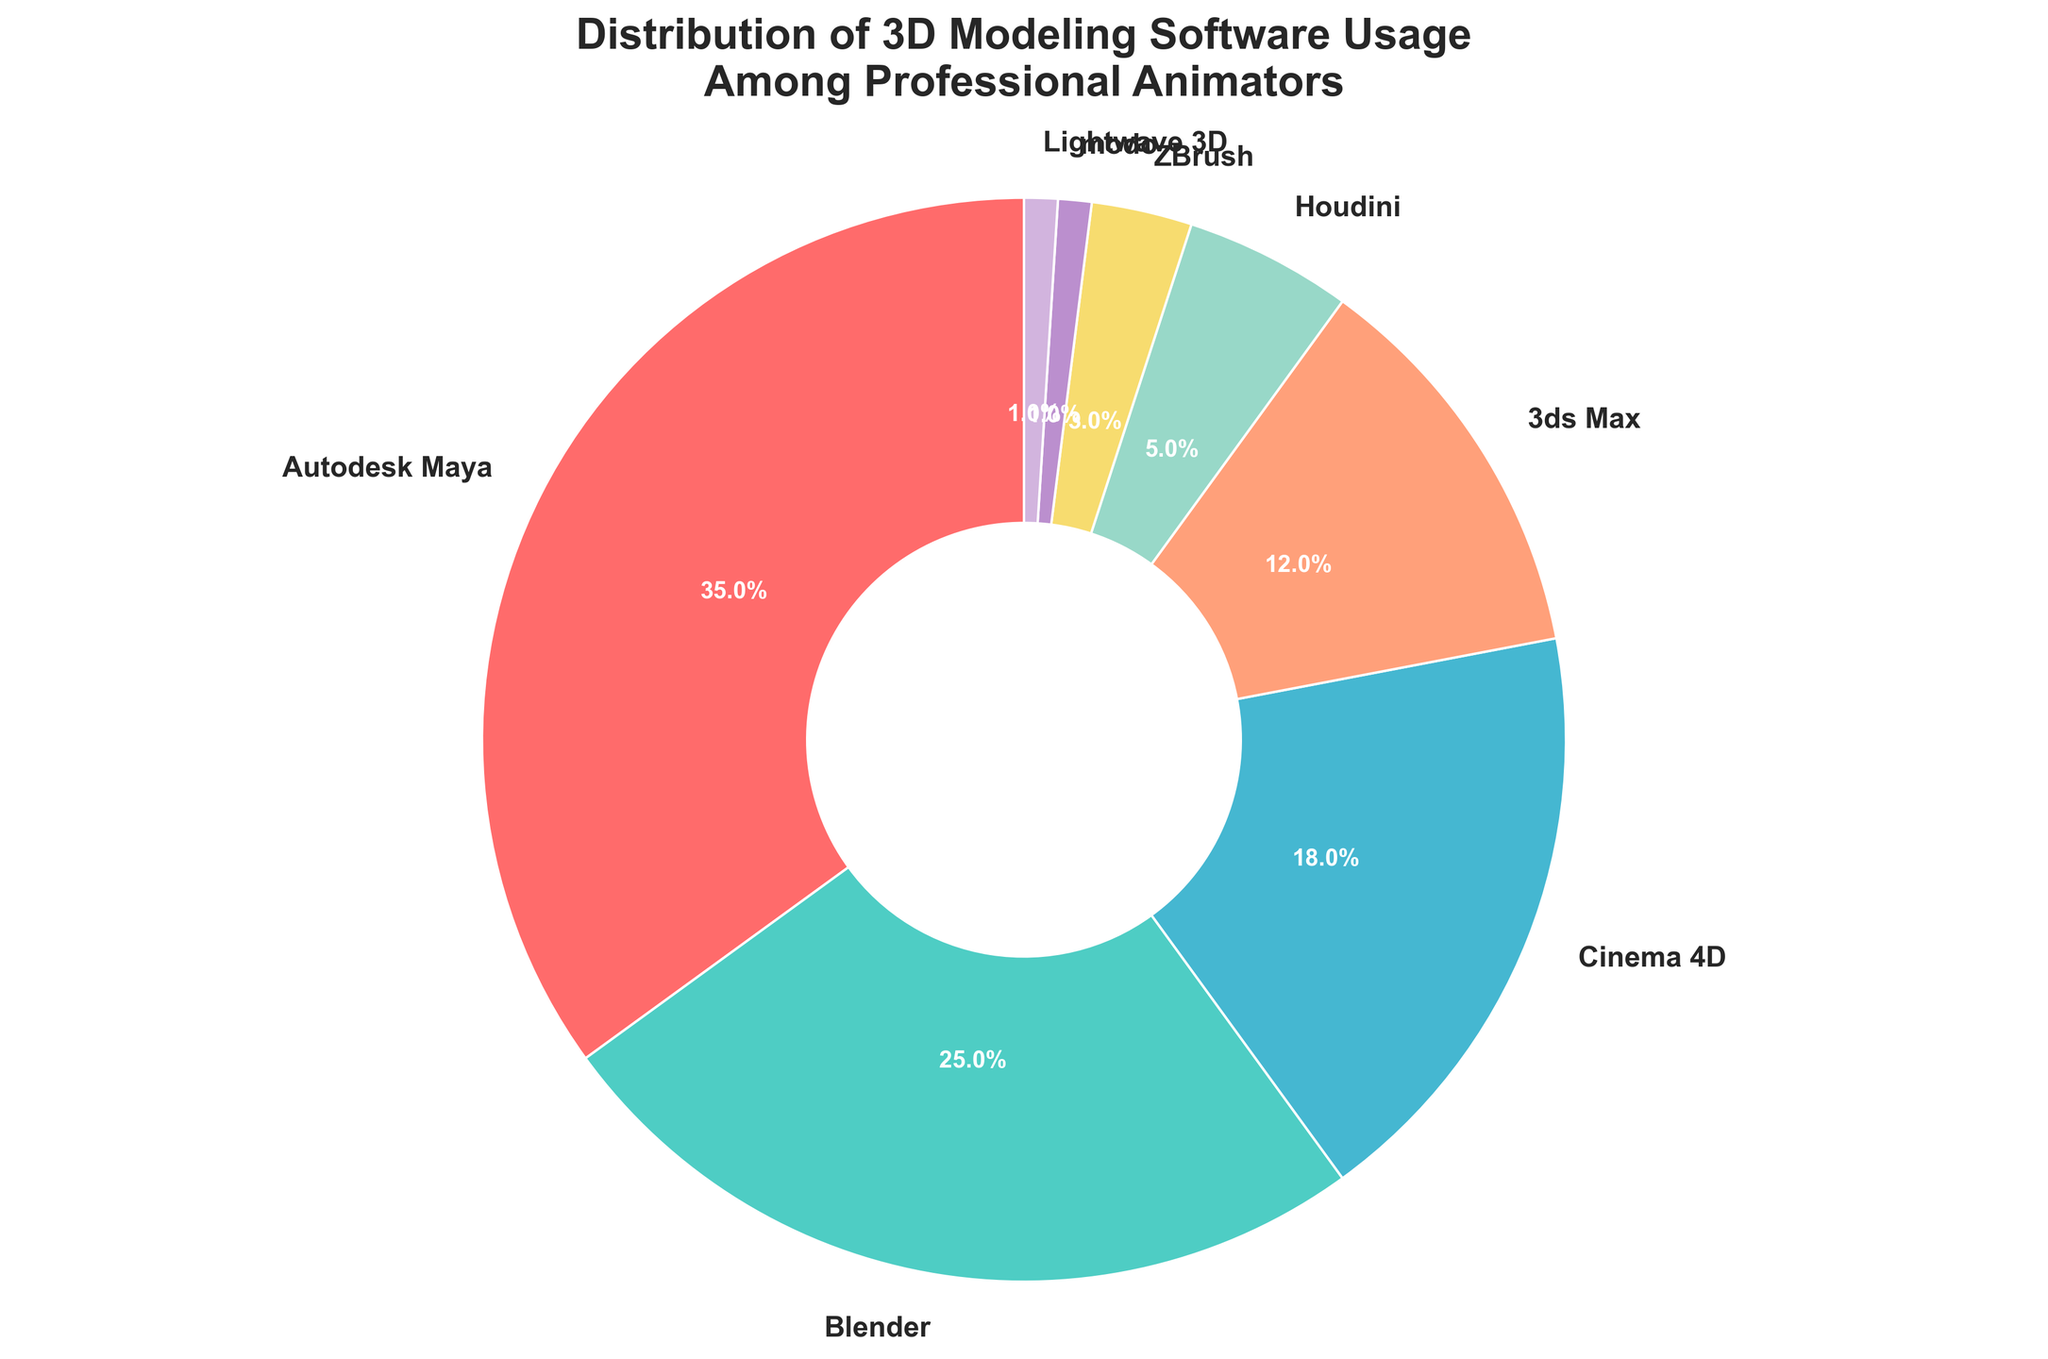What percentage of professional animators use Blender? By looking at the pie chart, find the section labeled "Blender" and read its percentage.
Answer: 25% Which software has the smallest usage percentage among professional animators? By examining the pie chart, identify the segment with the smallest slice, look for the label, which is "Lightwave 3D" or "modo".
Answer: Lightwave 3D or modo How much more popular is Autodesk Maya than 3ds Max? Note the percentages for both Autodesk Maya (35%) and 3ds Max (12%). Subtract the smaller percentage from the bigger one. 35 - 12 = 23
Answer: 23% What is the sum of the percentages for Cinema 4D and Houdini? Identify the percentages for Cinema 4D (18%) and Houdini (5%). Add them together: 18 + 5 = 23
Answer: 23% Which software has a larger share, Blender or Cinema 4D, and by how much? Note the percentages for Blender (25%) and Cinema 4D (18%). Subtract the smaller percentage from the bigger one. 25 - 18 = 7
Answer: Blender by 7% If you combine the usage of ZBrush, modo, and Lightwave 3D, what percentage do you get? Identify the percentages for ZBrush (3%), modo (1%), and Lightwave 3D (1%). Sum them up: 3 + 1 + 1 = 5
Answer: 5% What color represents 3ds Max in the pie chart? By examining the visual attribute (color) in the figure, look for the label "3ds Max" and note its associated color
Answer: Light salmon (FFA07A) Of the eight software listed, which has the third highest usage percentage among professional animators? By examining the pie chart, arrange the percentages in descending order: Autodesk Maya (35%), Blender (25%), and Cinema 4D (18%), with Cinema 4D being the third highest.
Answer: Cinema 4D What is the total percentage of usage for the top three most popular software? Identify the percentages for the top three software: Autodesk Maya (35%), Blender (25%), and Cinema 4D (18%). Add them together: 35 + 25 + 18 = 78
Answer: 78% How does the usage of Blender compare to Autodesk Maya? Compare the percentages directly: Blender (25%) versus Autodesk Maya (35%). Autodesk Maya is more popular.
Answer: Autodesk Maya is 10% more popular 